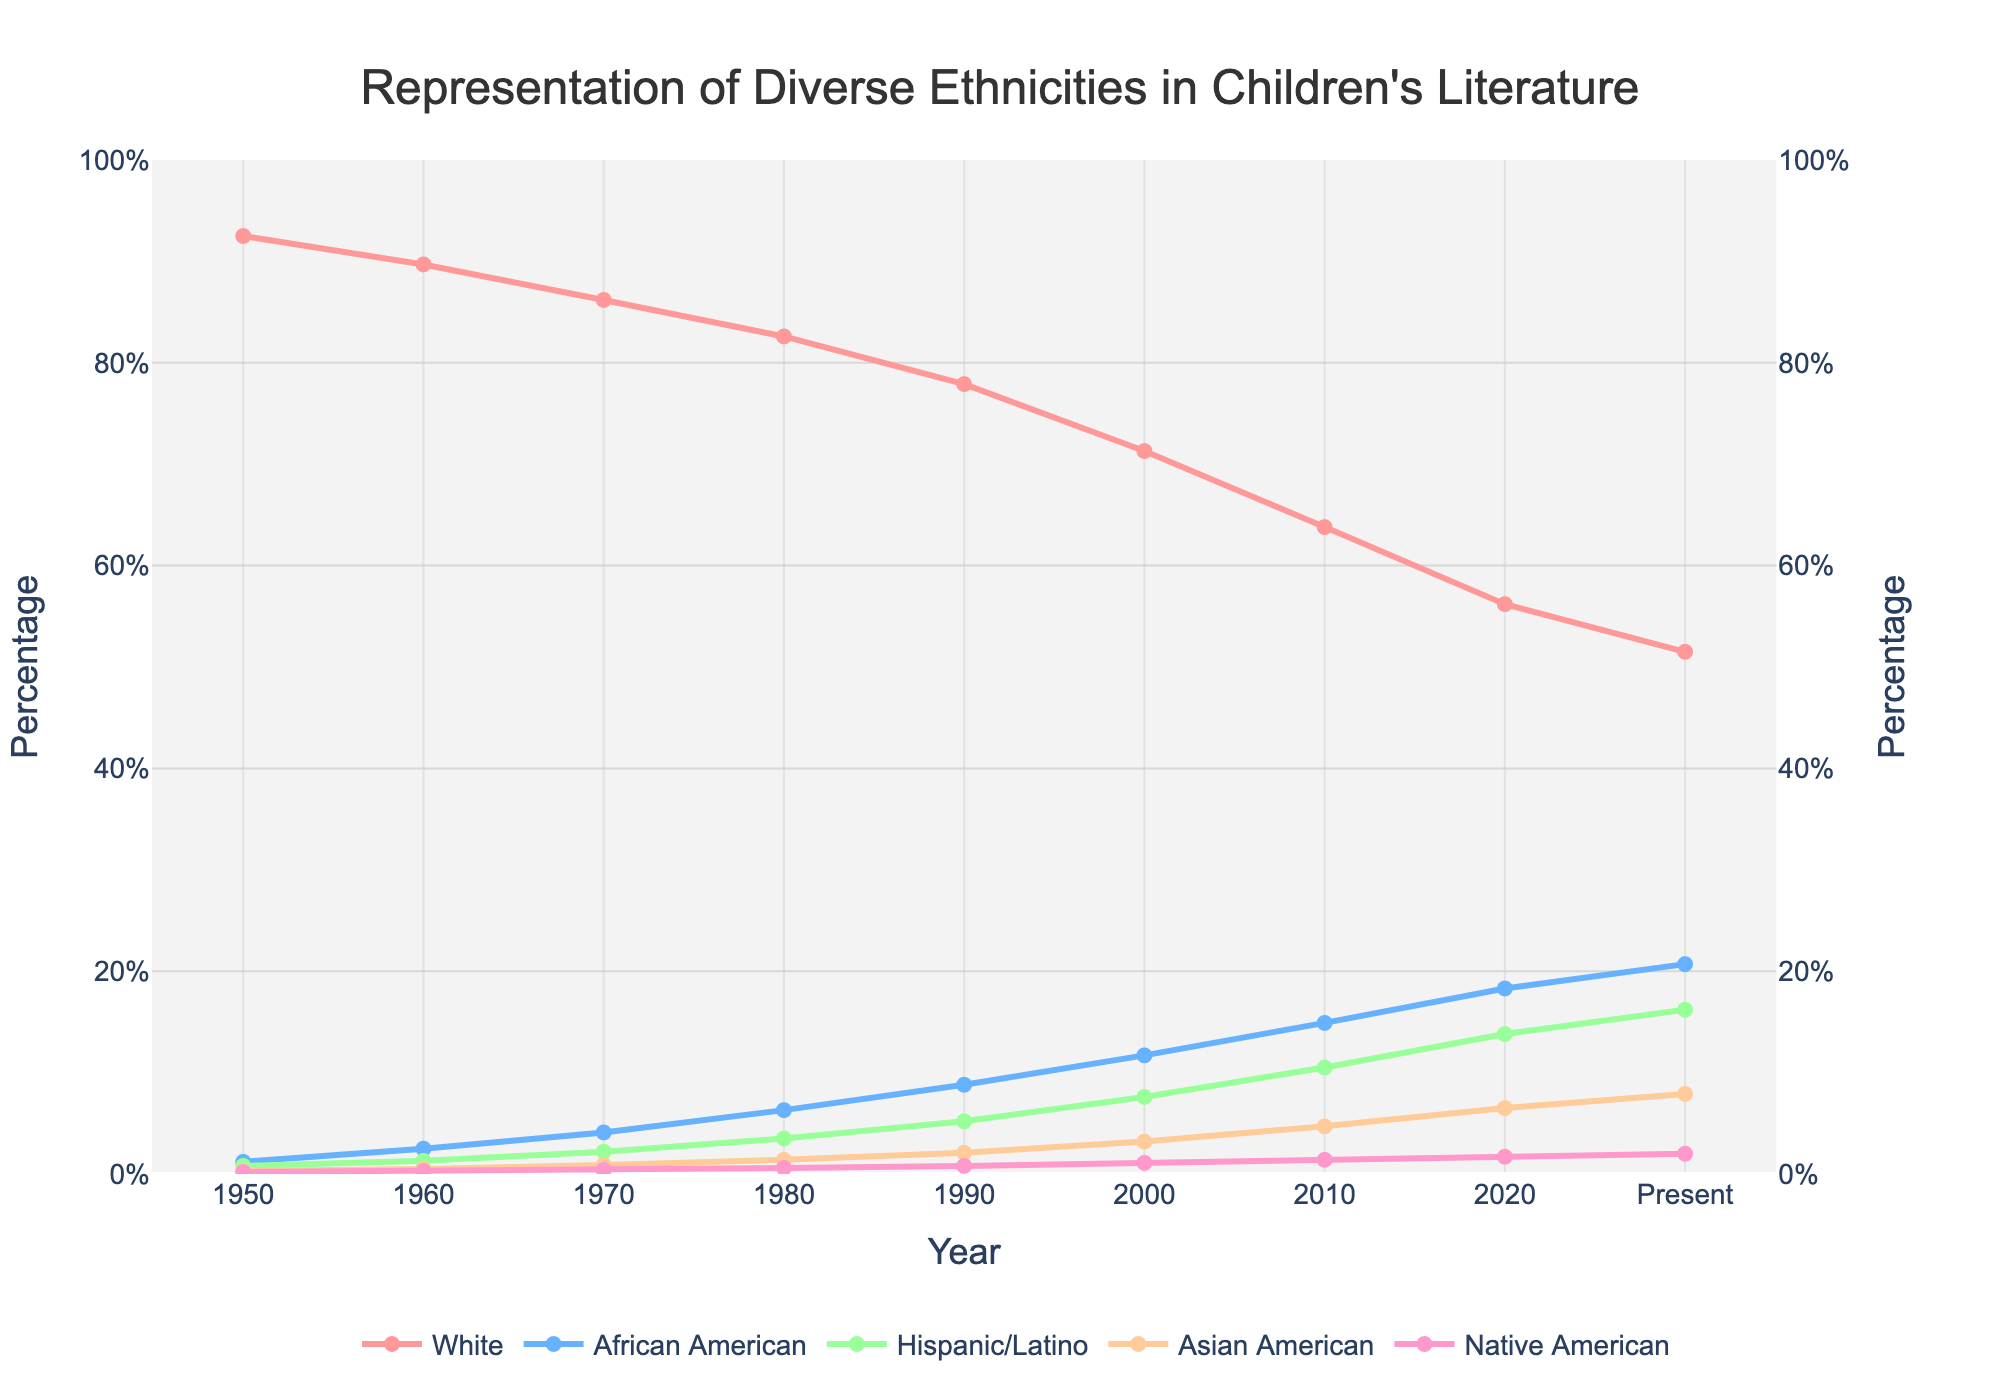Which ethnicity had the highest representation in children's literature in 1950? According to the figure, the line representing the "White" ethnicity is the highest in 1950, indicating it had the highest representation.
Answer: White What is the trend of representation for Asian Americans from 1950 to the present? By following the line corresponding to "Asian American" from 1950 to the present, it shows a gradual increase over the years.
Answer: Increasing How has the representation of African American characters changed from 1980 to 2000? Examining the line for "African American", its value increases from 6.3% in 1980 to 11.7% in 2000.
Answer: Increased What is the difference in the representation of Hispanic/Latino characters between 1990 and 2020? The representation in 1990 is 5.2%, and in 2020 it is 13.8%. The difference is 13.8% - 5.2%.
Answer: 8.6% Which ethnicity showed the most significant increase in representation from 1950 to the present? By comparing the starting and ending values for each ethnicity, African American increased from 1.2% in 1950 to 20.7% in the present, which is the largest increase.
Answer: African American Compare the representation of Native American characters in 1970 and 1990. Which year had a higher representation? The value in 1970 is 0.4%, and in 1990 it is 0.8%. Thus, 1990 had a higher representation.
Answer: 1990 What was the total representation percentage for minorities (excluding White) in 2000? Adding the percentages for African American (11.7%), Hispanic/Latino (7.6%), Asian American (3.2%), and Native American (1.1%) in 2000 gives the total representation for minorities: 11.7% + 7.6% + 3.2% + 1.1%.
Answer: 23.6% Which color line represents Asian American characters in the figure? The legend shows which color corresponds to each ethnicity. The Asian American characters are represented by a line.
Answer: Color corresponding to Asian American How does the representation of White characters in the present compare with their representation in 1950? The percentage of White characters in 1950 is 92.5%, while in the present it is 51.5%. This shows a decrease.
Answer: Decreased Considering the years 1980 to 2000, which ethnicity showed the most consistent growth in their representation? By examining the lines for each ethnicity between 1980 and 2000, African American characters show a consistent increase in representation each decade.
Answer: African American 